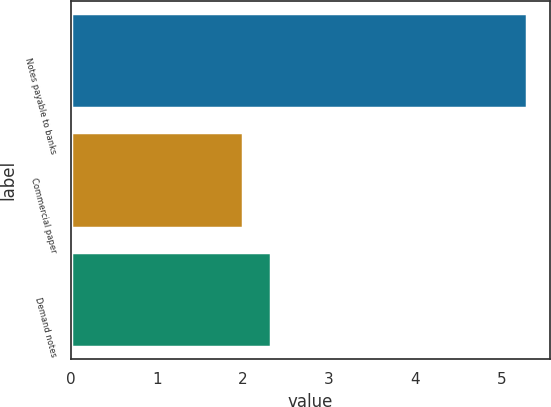Convert chart to OTSL. <chart><loc_0><loc_0><loc_500><loc_500><bar_chart><fcel>Notes payable to banks<fcel>Commercial paper<fcel>Demand notes<nl><fcel>5.3<fcel>2<fcel>2.33<nl></chart> 